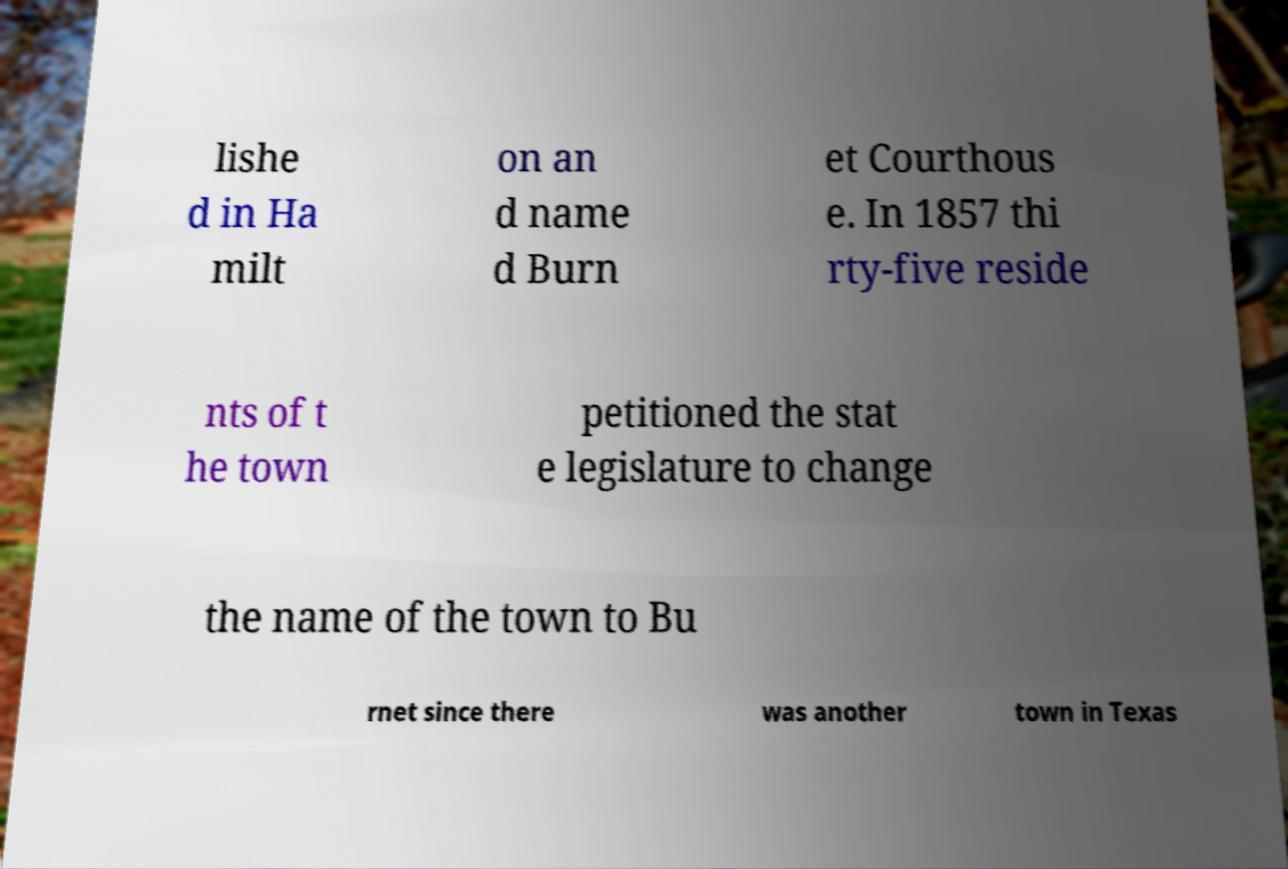Could you extract and type out the text from this image? lishe d in Ha milt on an d name d Burn et Courthous e. In 1857 thi rty-five reside nts of t he town petitioned the stat e legislature to change the name of the town to Bu rnet since there was another town in Texas 